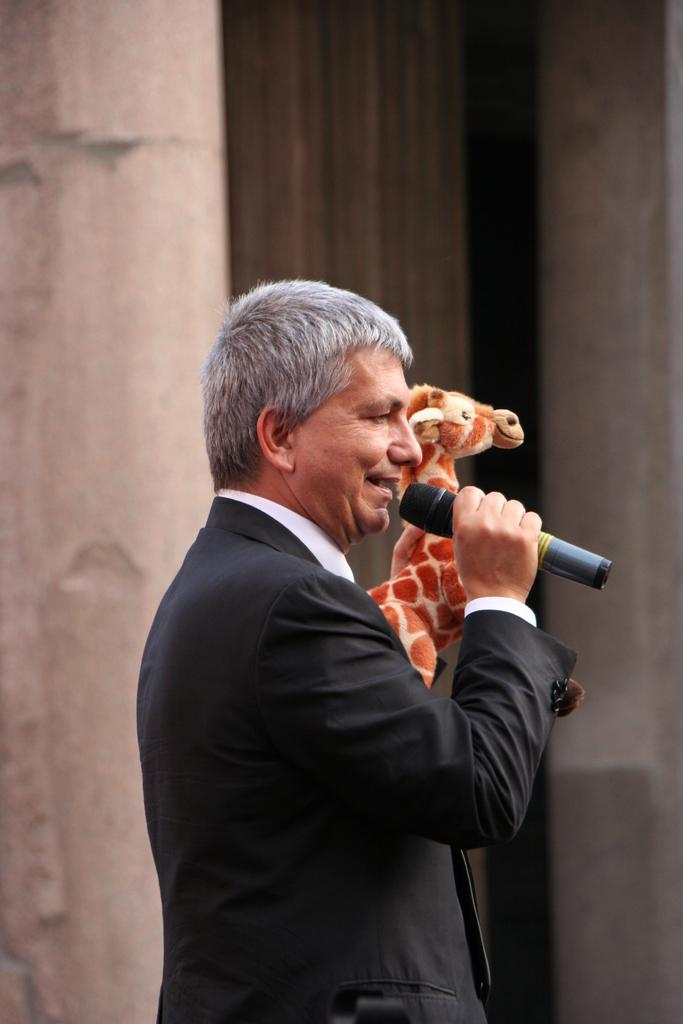What is the man in the image doing with his right hand? The man is holding a mic with his right hand. What is the man doing while holding the mic? The man is speaking. What can be seen in the background of the image? There is a pillar and a doll in the background of the image. What type of jam is the man spreading on the cracker in the image? There is no jam or cracker present in the image. 